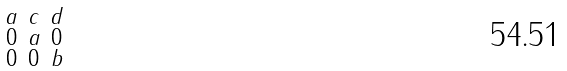<formula> <loc_0><loc_0><loc_500><loc_500>\begin{smallmatrix} a & c & d \\ 0 & a & 0 \\ 0 & 0 & b \end{smallmatrix}</formula> 